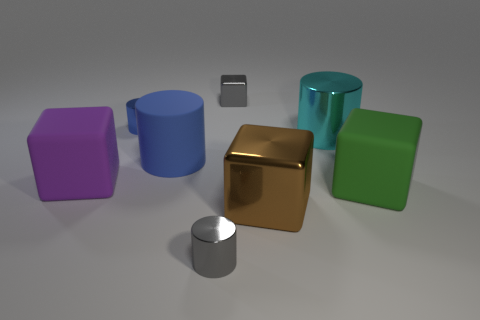Subtract all gray cubes. How many blue cylinders are left? 2 Subtract all large shiny cubes. How many cubes are left? 3 Add 1 big brown cubes. How many objects exist? 9 Subtract all gray cubes. How many cubes are left? 3 Subtract 2 blocks. How many blocks are left? 2 Subtract all purple cylinders. Subtract all green balls. How many cylinders are left? 4 Subtract all large blue rubber cylinders. Subtract all small blocks. How many objects are left? 6 Add 8 gray blocks. How many gray blocks are left? 9 Add 7 large matte cylinders. How many large matte cylinders exist? 8 Subtract 1 gray cubes. How many objects are left? 7 